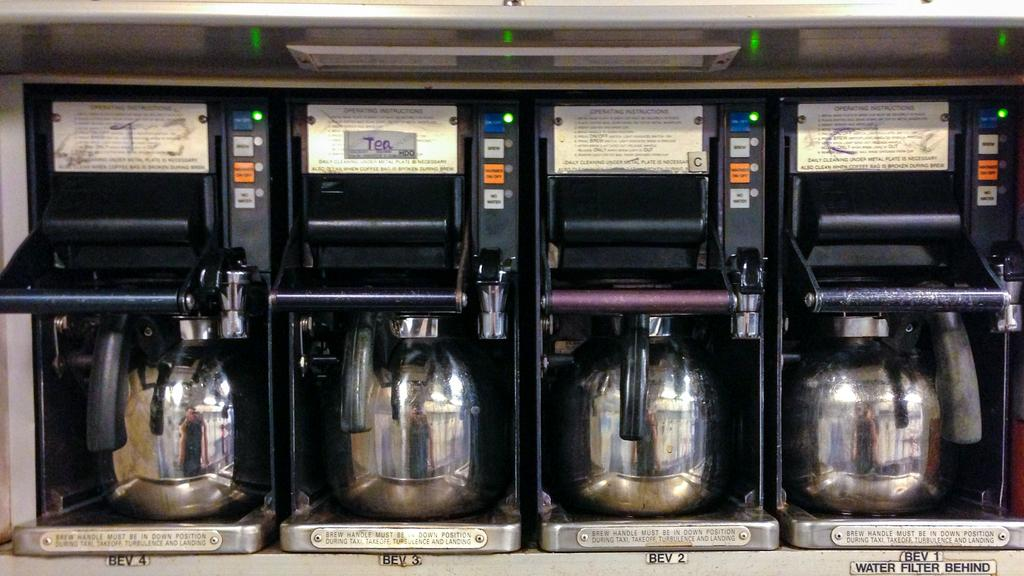<image>
Relay a brief, clear account of the picture shown. Four coffee makers lined up next to one another and one says tea on it. 